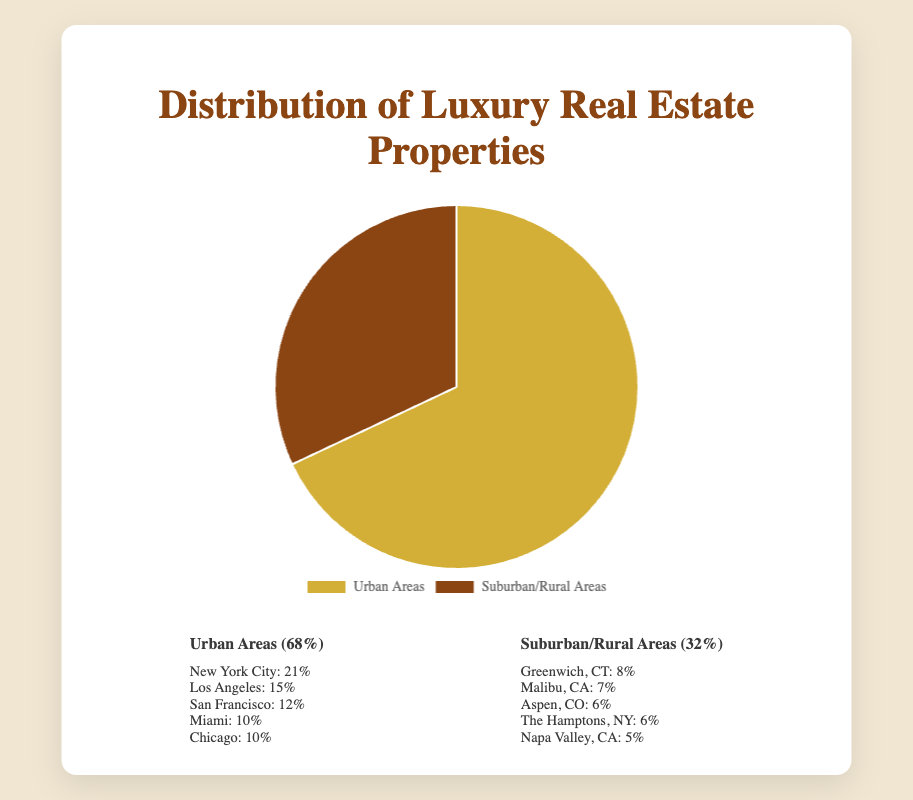What percentage of luxury real estate properties are in suburban/rural areas? The pie chart shows that the suburban/rural areas category covers 32% of the total luxury real estate properties. You can directly read this value from the chart.
Answer: 32% How much more common are luxury real estate properties in urban areas compared to suburban/rural areas? The urban areas have 68% while the suburban/rural areas have 32%. The difference is 68% - 32%.
Answer: 36% What's the total percentage share of the top two cities in urban areas? The top two cities in urban areas are New York City (21%) and Los Angeles (15%). The combined percentage is 21% + 15%.
Answer: 36% Which area, urban or suburban/rural, is represented with a gold color? The pie chart uses gold color for urban areas, as described in the legend.
Answer: Urban areas Rank the cities in suburban/rural areas from highest to lowest percentage share. Refer to the legend for suburban/rural areas: Greenwich, CT (8%), Malibu, CA (7%), Aspen, CO (6%), The Hamptons, NY (6%), Napa Valley, CA (5%).
Answer: Greenwich > Malibu > Aspen = The Hamptons > Napa Valley Which urban area occupies the smallest percentage share and what is it? From the legend, the city with the smallest percentage in urban areas is Miami, with 10%.
Answer: Miami, 10% If you combine the percentage shares of San Francisco and Miami in urban areas, what would be the result? San Francisco has 12% and Miami has 10%. Adding these figures gives 12% + 10%.
Answer: 22% Compare the summed percentage of Miami and Chicago to Greenwich, CT. Which is larger and by how much? Miami and Chicago together have 10% + 10% = 20%. Greenwich, CT has 8%. The difference is 20% - 8%.
Answer: Miami and Chicago, by 12% What's the visual representation (color) for suburban/rural areas on the pie chart? The pie chart uses a brownish color for suburban/rural areas, as indicated in the legend.
Answer: Brown Which area, urban or suburban/rural, has a larger variety of listed locations? Urban areas list five specific places in the legend, while suburban/rural areas also list five. Therefore, both regions list an equal number of locations.
Answer: Both 